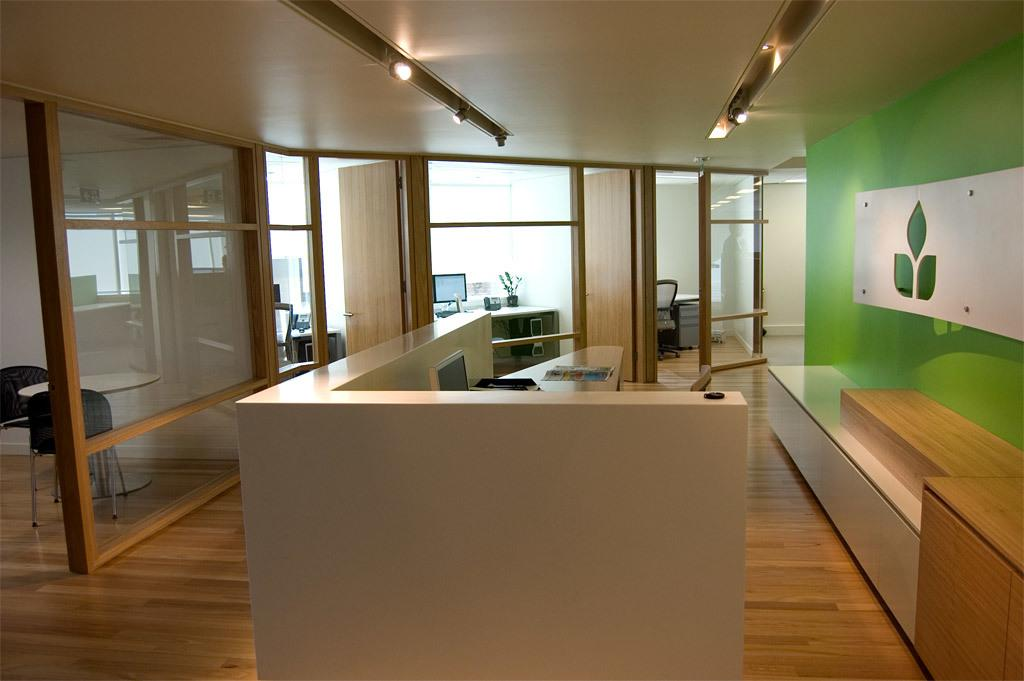What type of structures are visible in the image? There are cabins in the image. What electronic devices can be seen in the image? There are computers in the image. What type of spaces are depicted in the image? There are rooms in the image. What type of tableware is present in the image? There are glasses in the image. What type of seating is on the right side of the image? There is a wooden bench on the right side of the image. What is behind the wooden bench in the image? There is a wall behind the wooden bench. What type of nut is used to secure the computers to the wall in the image? There is no mention of nuts or the computers being secured to the wall in the image. What type of mint is growing on the wooden bench in the image? There is no mint or any plants visible on the wooden bench in the image. 